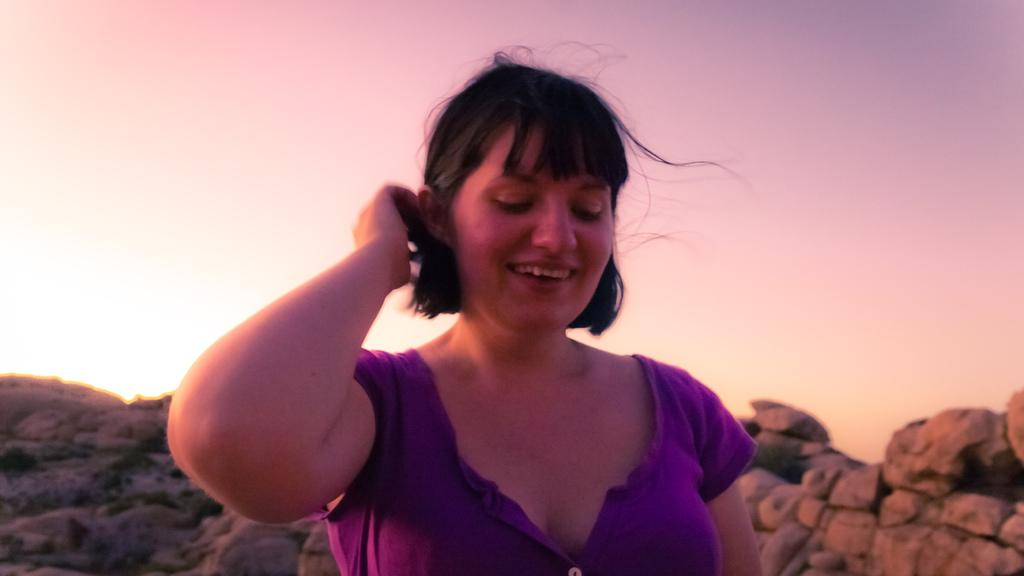Who is present in the image? There is a woman in the image. What is the woman's facial expression? The woman is smiling. What type of natural feature can be seen in the image? There are rocks in the image. What is visible in the background of the image? The sky is visible in the background of the image. What type of pies can be seen in the image? There are no pies present in the image. Where is the park located in the image? There is no park present in the image. 